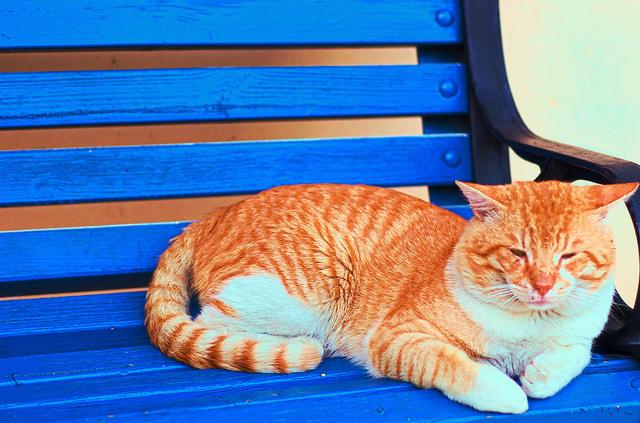What is the cat sitting on?
Be succinct. Bench. Is this cat content?
Give a very brief answer. Yes. What color is the bench?
Short answer required. Blue. 